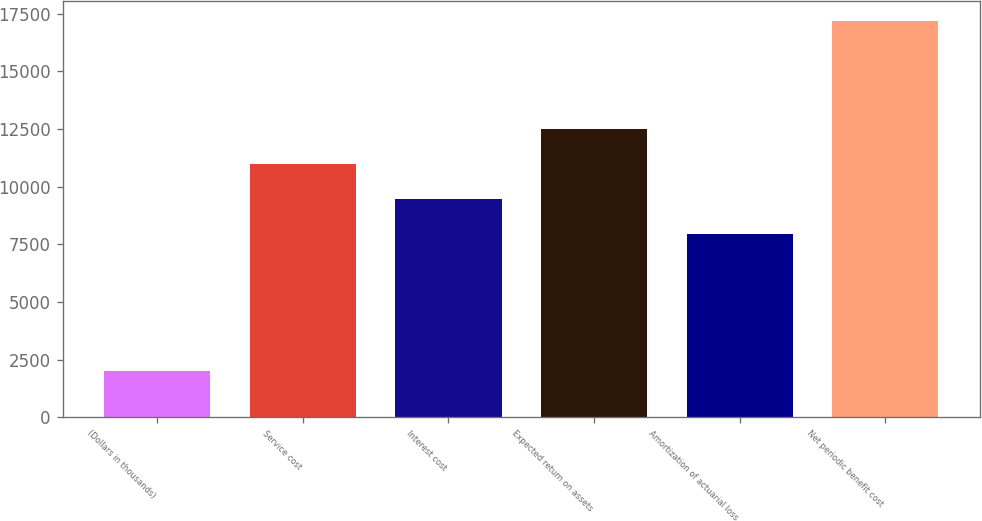Convert chart to OTSL. <chart><loc_0><loc_0><loc_500><loc_500><bar_chart><fcel>(Dollars in thousands)<fcel>Service cost<fcel>Interest cost<fcel>Expected return on assets<fcel>Amortization of actuarial loss<fcel>Net periodic benefit cost<nl><fcel>2016<fcel>11002.2<fcel>9485<fcel>12519.4<fcel>7937<fcel>17188<nl></chart> 